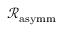<formula> <loc_0><loc_0><loc_500><loc_500>\mathcal { R } _ { a s y m m }</formula> 